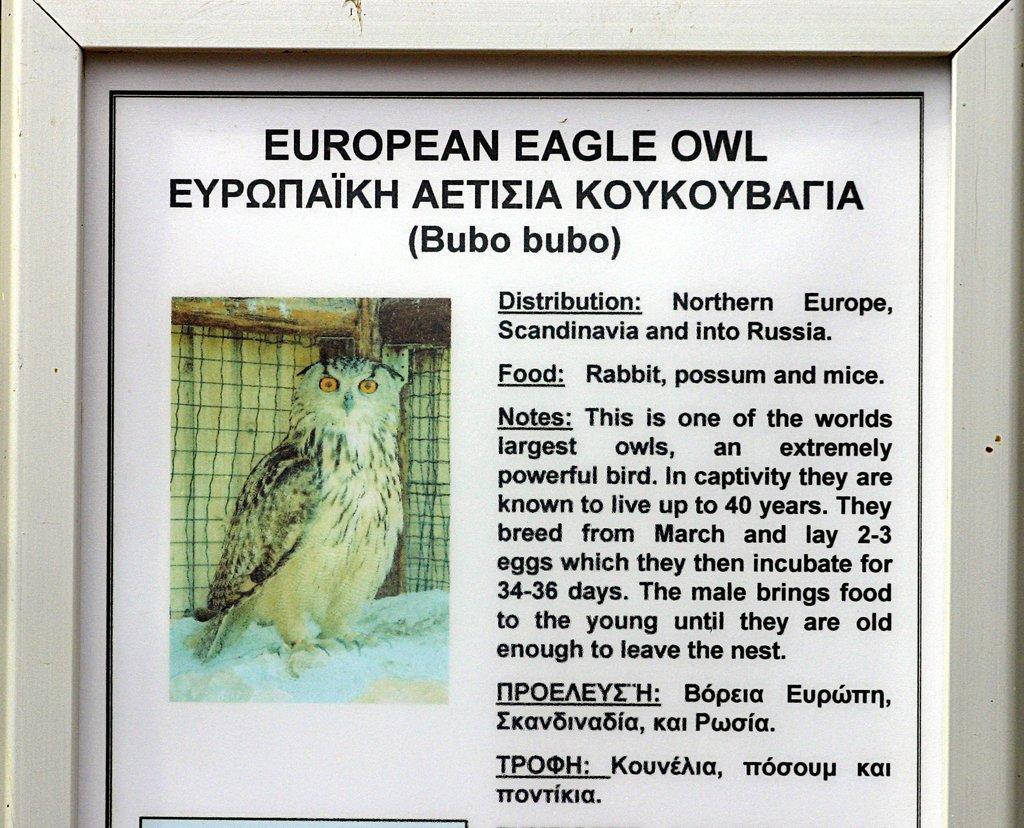What is the main subject of the image? The main subject of the image is a photo frame. What is depicted inside the photo frame? There is an owl in the photo frame. What color is the text in the photo frame? The text in the photo frame is written in black color. What is the color of the background in the photo frame? The background of the photo frame is white in color. What type of ray can be seen swimming in the photo frame? There is no ray present in the photo frame; it contains an owl. Who is the owner of the owl in the photo frame? The image does not provide information about the owner of the owl. 